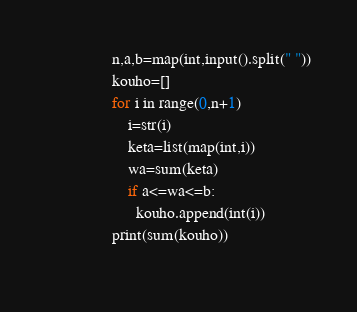Convert code to text. <code><loc_0><loc_0><loc_500><loc_500><_Python_>                n,a,b=map(int,input().split(" "))
                kouho=[]
                for i in range(0,n+1)
                	i=str(i)
                	keta=list(map(int,i))
                	wa=sum(keta)
                    if a<=wa<=b:
                      kouho.append(int(i))
                print(sum(kouho))
                 </code> 